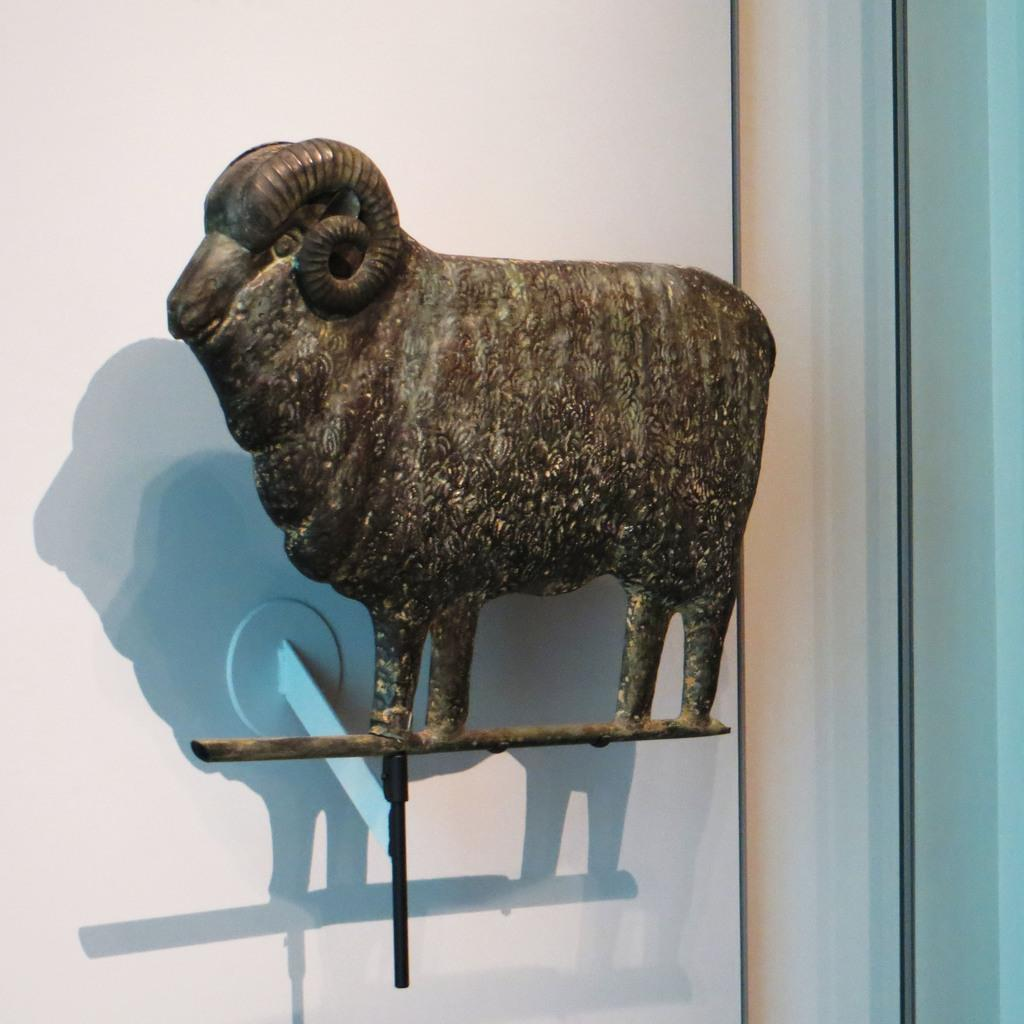What is the main subject of the image? There is a statue in the image. What is the statue shaped like? The statue is in the shape of a sheep. What color is the background of the image? The background of the image is white. What type of face can be seen on the sheep statue in the image? There is no face visible on the sheep statue in the image, as it is a statue and not a living creature. 